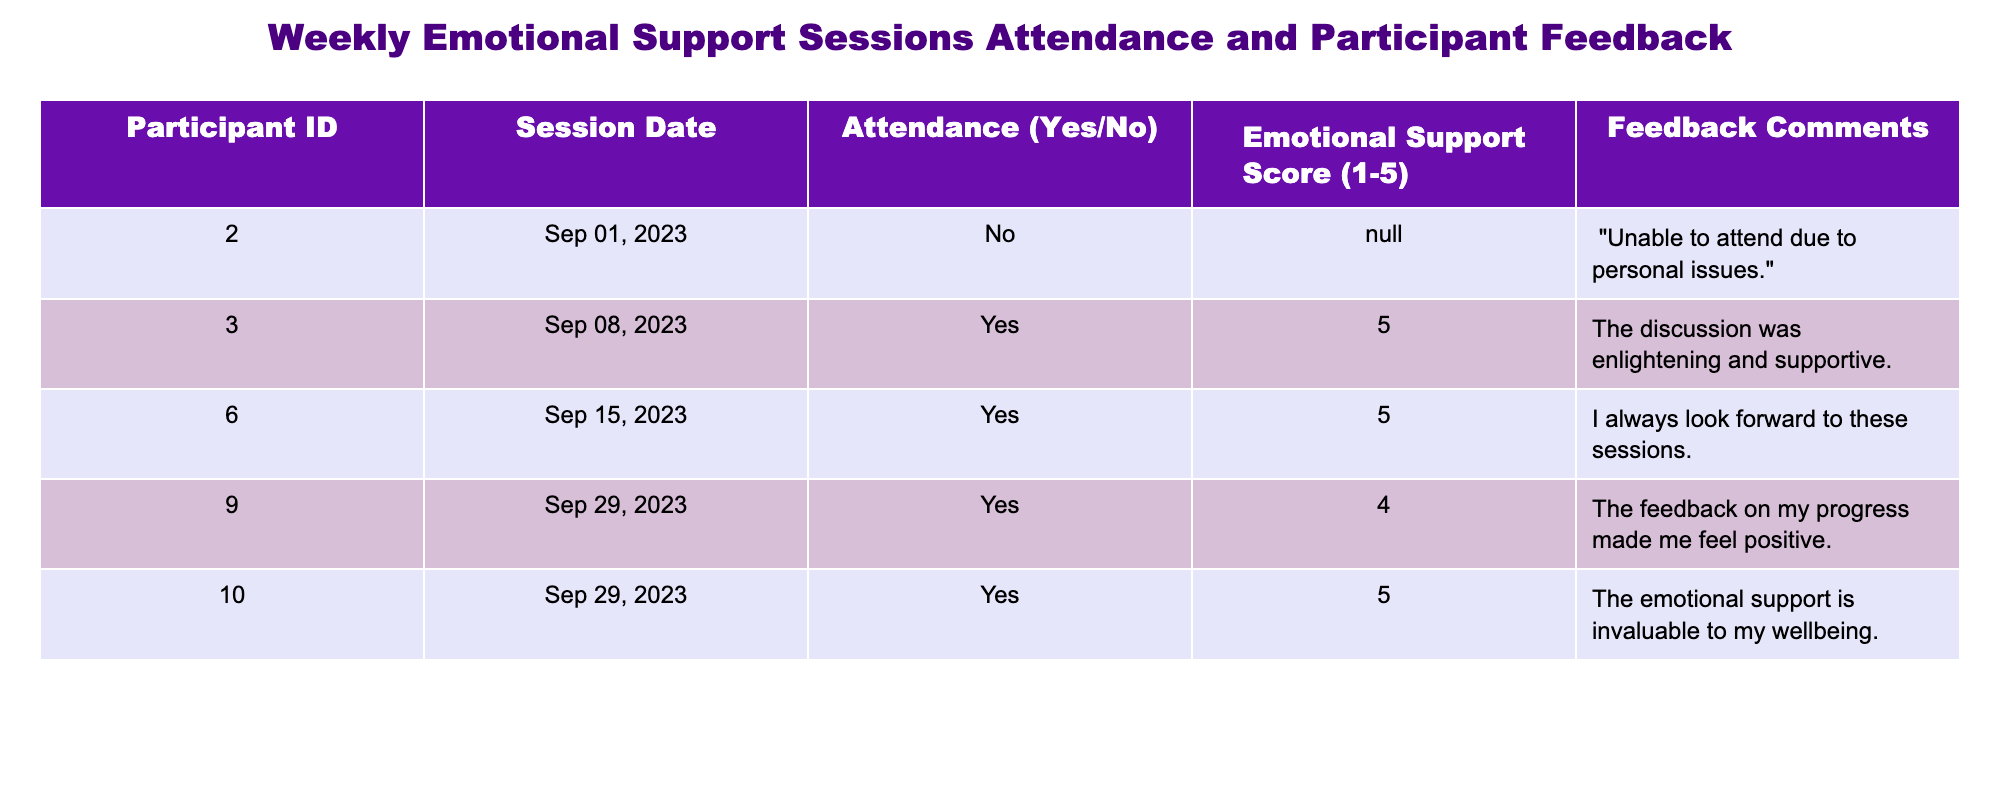What was the attendance of Participant ID 003 on September 8, 2023? According to the table, Participant ID 003 attended the session on September 8, 2023, as indicated in the "Attendance" column where it states "Yes".
Answer: Yes How many participants provided a feedback score of 5? From the table, we can see that there are two participants (ID 003 and ID 010) who gave a score of 5. Thus, the total count is 2.
Answer: 2 What is the emotional support score for the participant who attended on September 29, 2023? Reviewing the table, we find two participants attended on September 29, 2023: Participant ID 009 with a score of 4 and Participant ID 010 with a score of 5.
Answer: Participants had scores of 4 and 5 Did any participant miss a session due to personal issues? Yes, Participant ID 002 did not attend the session on September 1, 2023, due to personal issues as mentioned in the feedback comments.
Answer: Yes What is the average emotional support score for participants who attended the sessions? We take the scores from participants who attended (5, 5, 4, and 5), which sum to 19. There are 4 participants who attended, so the average score is calculated as 19/4 = 4.75.
Answer: 4.75 How many sessions did participants attend with scores greater than 3? Looking at the scores in the table, each of the sessions attended by participants ID 003, ID 006, ID 009, and ID 010 scored more than 3 (5, 5, 4, 5), leading to a total of 4 sessions.
Answer: 4 What feedback comment did participant ID 010 provide? The comment for participant ID 010 is listed in the "Feedback Comments" as "The emotional support is invaluable to my wellbeing."
Answer: The emotional support is invaluable to my wellbeing Which participant had the highest emotional support score? Participant ID 003 and ID 010 both received the highest score of 5. Thus, the highest score among participants is 5.
Answer: ID 003 and ID 010 had the highest score 